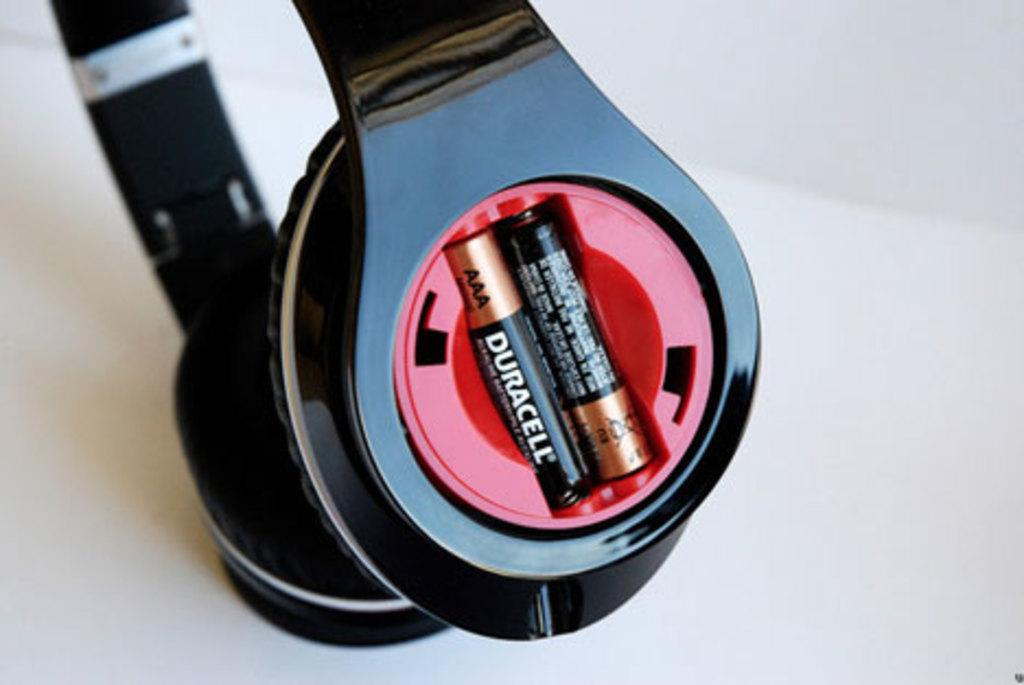Provide a one-sentence caption for the provided image. two duracell batteries in a pair of over ear headphones. 